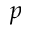Convert formula to latex. <formula><loc_0><loc_0><loc_500><loc_500>p</formula> 